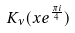<formula> <loc_0><loc_0><loc_500><loc_500>K _ { \nu } ( x e ^ { \frac { \pi i } { 4 } } )</formula> 